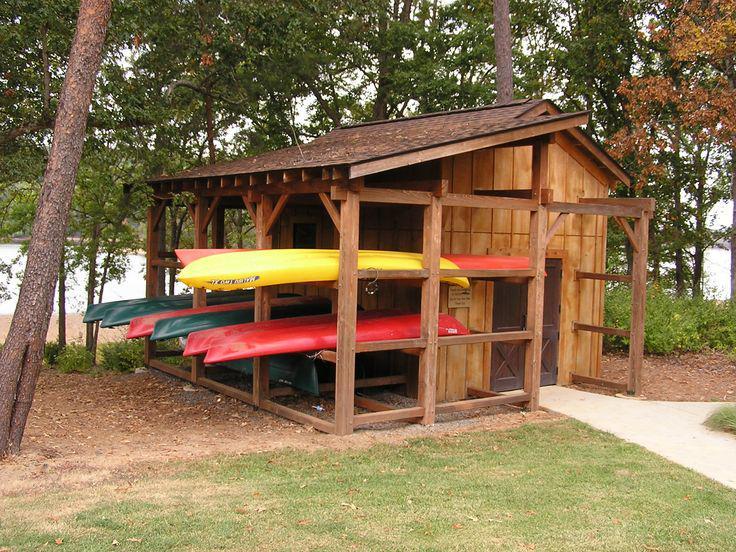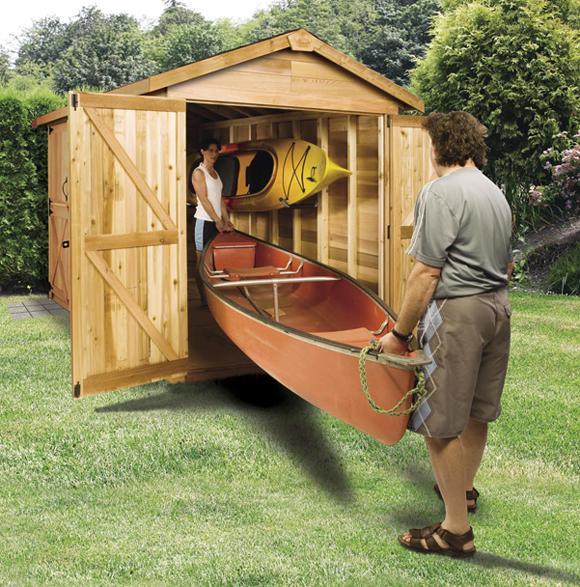The first image is the image on the left, the second image is the image on the right. Evaluate the accuracy of this statement regarding the images: "There is at least one boat in storage.". Is it true? Answer yes or no. Yes. The first image is the image on the left, the second image is the image on the right. Examine the images to the left and right. Is the description "there are two boats in the image pair" accurate? Answer yes or no. No. 